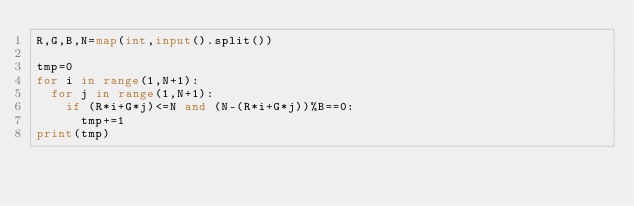<code> <loc_0><loc_0><loc_500><loc_500><_Python_>R,G,B,N=map(int,input().split())

tmp=0
for i in range(1,N+1):
  for j in range(1,N+1):
    if (R*i+G*j)<=N and (N-(R*i+G*j))%B==0:
      tmp+=1
print(tmp)</code> 